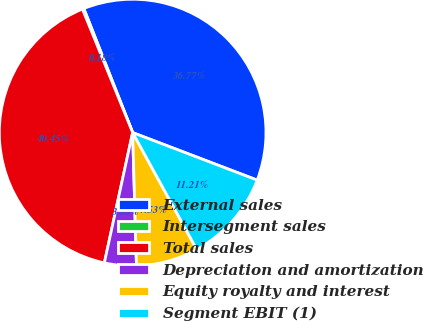Convert chart to OTSL. <chart><loc_0><loc_0><loc_500><loc_500><pie_chart><fcel>External sales<fcel>Intersegment sales<fcel>Total sales<fcel>Depreciation and amortization<fcel>Equity royalty and interest<fcel>Segment EBIT (1)<nl><fcel>36.77%<fcel>0.18%<fcel>40.45%<fcel>3.86%<fcel>7.53%<fcel>11.21%<nl></chart> 